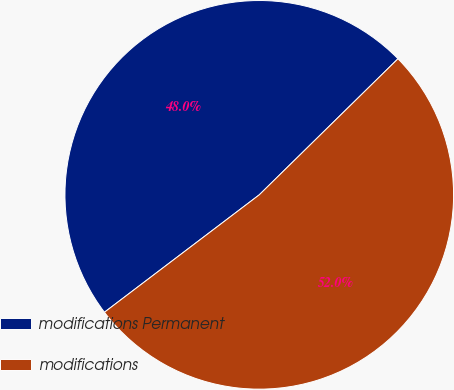Convert chart to OTSL. <chart><loc_0><loc_0><loc_500><loc_500><pie_chart><fcel>modifications Permanent<fcel>modifications<nl><fcel>47.98%<fcel>52.02%<nl></chart> 